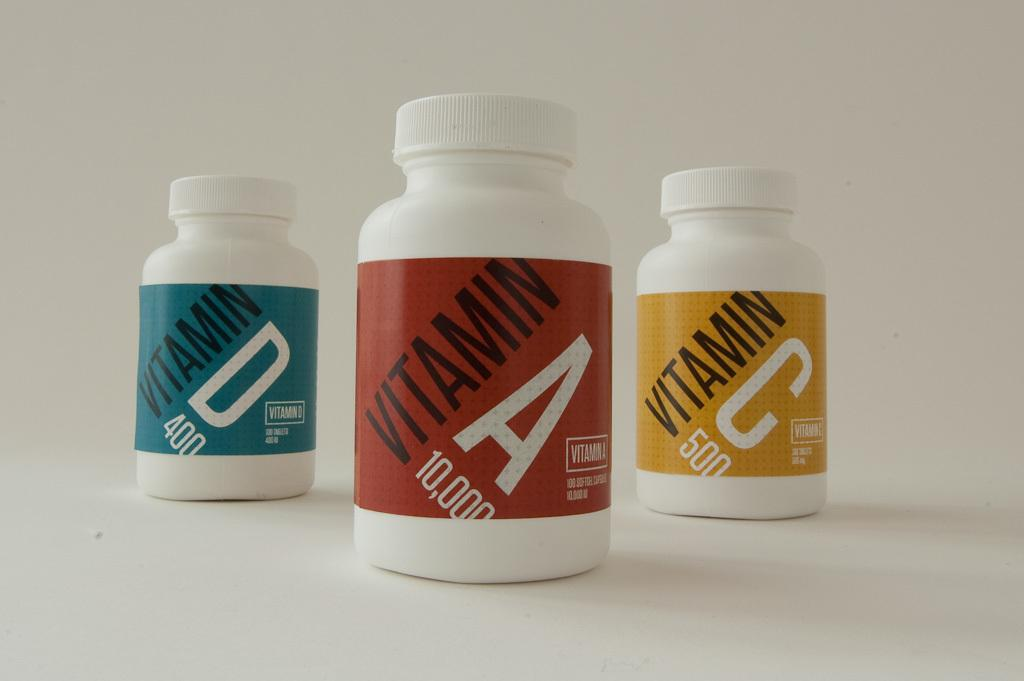How many vitamin bottles are in the image? There are three vitamin bottles in the image. What color is the bottle containing Vitamin A? Vitamin A is in a red bottle. What color is the bottle containing Vitamin C? Vitamin C is in a yellow bottle. What color is the bottle containing Vitamin D? Vitamin D is in a blue bottle. What type of underwear is being worn by the person in the image? There is no person present in the image, so it is not possible to determine what type of underwear they might be wearing. 